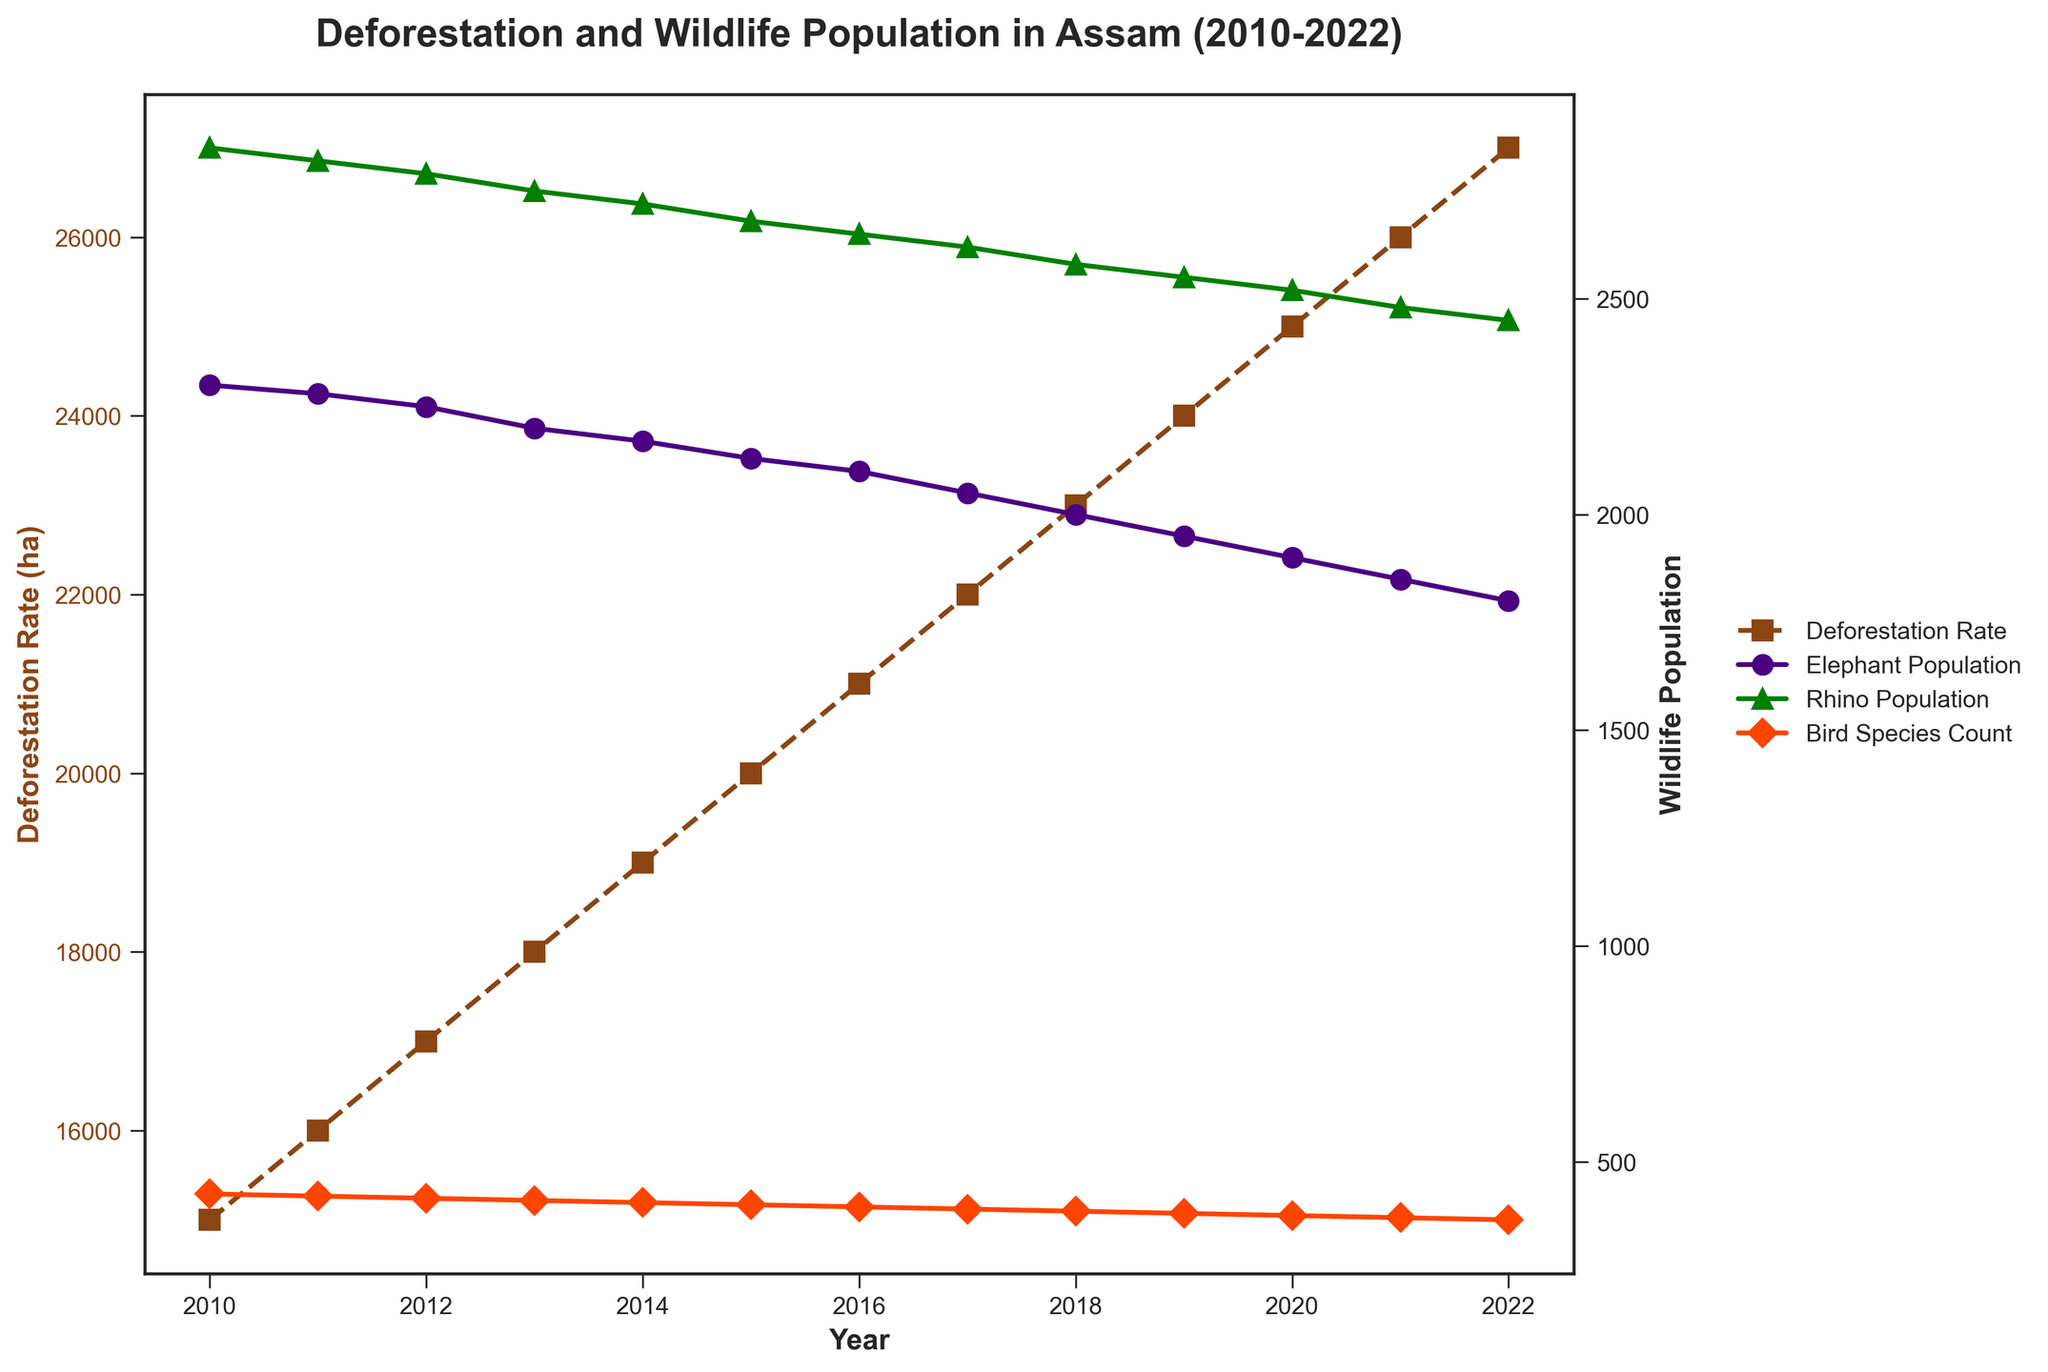What is the title of the plot? The title of the plot is located at the top and is written in a bold font. It helps describe what the plot represents. Reading the title, we see it states: "Deforestation and Wildlife Population in Assam (2010-2022)".
Answer: "Deforestation and Wildlife Population in Assam (2010-2022)" How many years are covered in the plot? The x-axis shows the years from 2010 to 2022. Counting these, we see there are 13 years in total.
Answer: 13 What color represents the deforestation rate line? The color of the deforestation rate line can be identified by looking at the plot's legend and matching it to the corresponding line. The legend shows that the deforestation rate is represented by a brown-colored line.
Answer: brown Which wildlife population had the steepest decline over the observed period? By observing the slopes of the lines representing each wildlife population on the plot, we can determine which one has the steepest decline. The elephant population shows the steepest decline as its line descends the most sharply.
Answer: Elephant Population What was the deforestation rate in 2015? To find this, locate the year 2015 on the x-axis and then trace upwards to the brown line representing the deforestation rate. The corresponding y-axis value tells us this rate. The rate for 2015 was 20,000 hectares.
Answer: 20,000 hectares How did the bird species count change from 2010 to 2022? Observing the orange line which represents the bird species count, trace from the year 2010 to 2022. The bird species count decreased from 425 in 2010 to 365 in 2022.
Answer: It decreased from 425 to 365 Which year had the highest rhino population, and what was it? By tracing the green line representing rhino population, we see the highest value and find the corresponding year on the x-axis. The highest rhino population was in 2010 with a population of 2850.
Answer: 2010, 2850 How many bird species were lost between 2010 and 2022? Calculate the difference in bird species count between the years 2010 and 2022 by subtracting the latter from the former. The bird species count in 2010 was 425 and in 2022 was 365, thus 425 - 365 = 60 species were lost.
Answer: 60 species In which year did the elephant population drop below 2000? Look for the point at which the purple line representing the elephant population crosses below the 2000 mark. Tracing the year from this point on the x-axis, we see it happens in 2018.
Answer: 2018 What trend do you observe in the relationship between deforestation rates and wildlife populations? By comparing the trend lines, we see that as deforestation rates (brown line) increased from 2010 to 2022, all wildlife populations (all corresponding lines) showed a downward trend. This suggests an inverse relationship.
Answer: Inverse relationship: as deforestation increases, wildlife populations decrease 